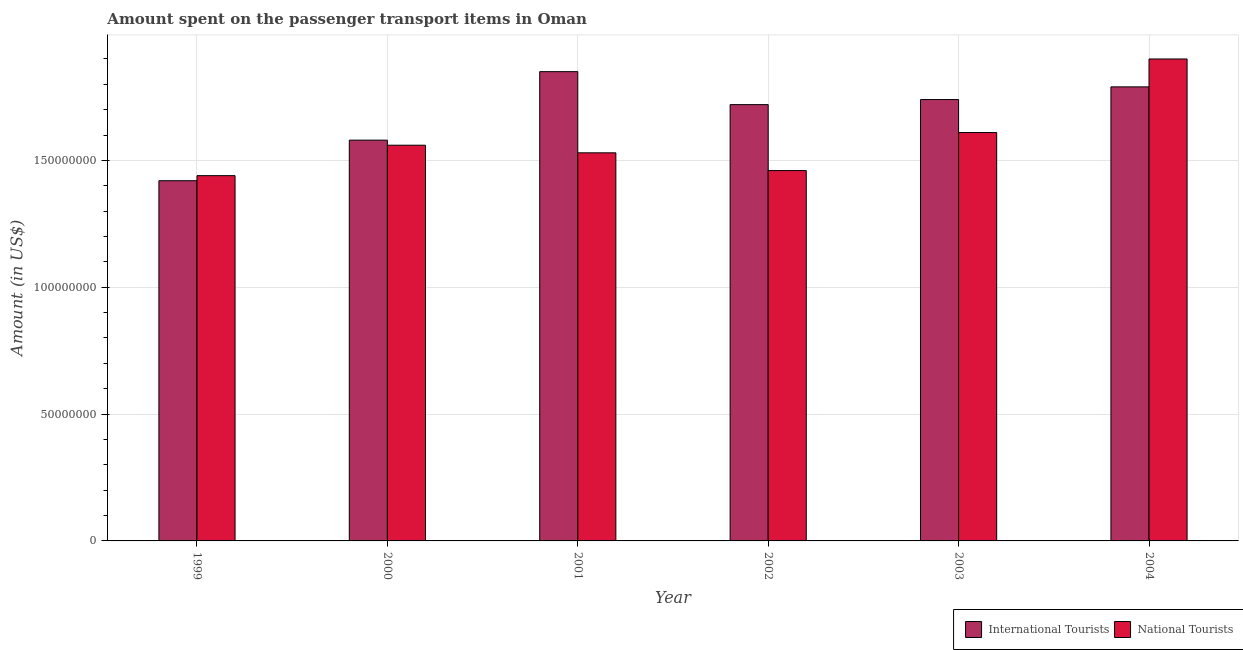How many groups of bars are there?
Provide a succinct answer. 6. How many bars are there on the 4th tick from the left?
Give a very brief answer. 2. What is the label of the 4th group of bars from the left?
Ensure brevity in your answer.  2002. In how many cases, is the number of bars for a given year not equal to the number of legend labels?
Offer a terse response. 0. What is the amount spent on transport items of international tourists in 2001?
Your answer should be compact. 1.85e+08. Across all years, what is the maximum amount spent on transport items of national tourists?
Offer a very short reply. 1.90e+08. Across all years, what is the minimum amount spent on transport items of national tourists?
Provide a succinct answer. 1.44e+08. What is the total amount spent on transport items of national tourists in the graph?
Keep it short and to the point. 9.50e+08. What is the difference between the amount spent on transport items of national tourists in 2001 and that in 2004?
Offer a terse response. -3.70e+07. What is the difference between the amount spent on transport items of national tourists in 2000 and the amount spent on transport items of international tourists in 2001?
Make the answer very short. 3.00e+06. What is the average amount spent on transport items of national tourists per year?
Your answer should be compact. 1.58e+08. In how many years, is the amount spent on transport items of international tourists greater than 70000000 US$?
Give a very brief answer. 6. What is the ratio of the amount spent on transport items of international tourists in 2000 to that in 2003?
Provide a succinct answer. 0.91. What is the difference between the highest and the second highest amount spent on transport items of national tourists?
Offer a very short reply. 2.90e+07. What is the difference between the highest and the lowest amount spent on transport items of international tourists?
Offer a terse response. 4.30e+07. What does the 1st bar from the left in 2000 represents?
Your answer should be compact. International Tourists. What does the 2nd bar from the right in 2004 represents?
Ensure brevity in your answer.  International Tourists. How many bars are there?
Offer a terse response. 12. How many years are there in the graph?
Provide a short and direct response. 6. What is the difference between two consecutive major ticks on the Y-axis?
Provide a succinct answer. 5.00e+07. How many legend labels are there?
Give a very brief answer. 2. How are the legend labels stacked?
Offer a very short reply. Horizontal. What is the title of the graph?
Provide a succinct answer. Amount spent on the passenger transport items in Oman. What is the label or title of the X-axis?
Provide a short and direct response. Year. What is the label or title of the Y-axis?
Offer a very short reply. Amount (in US$). What is the Amount (in US$) in International Tourists in 1999?
Offer a very short reply. 1.42e+08. What is the Amount (in US$) in National Tourists in 1999?
Offer a very short reply. 1.44e+08. What is the Amount (in US$) in International Tourists in 2000?
Keep it short and to the point. 1.58e+08. What is the Amount (in US$) in National Tourists in 2000?
Ensure brevity in your answer.  1.56e+08. What is the Amount (in US$) of International Tourists in 2001?
Keep it short and to the point. 1.85e+08. What is the Amount (in US$) in National Tourists in 2001?
Ensure brevity in your answer.  1.53e+08. What is the Amount (in US$) of International Tourists in 2002?
Keep it short and to the point. 1.72e+08. What is the Amount (in US$) in National Tourists in 2002?
Keep it short and to the point. 1.46e+08. What is the Amount (in US$) of International Tourists in 2003?
Provide a succinct answer. 1.74e+08. What is the Amount (in US$) in National Tourists in 2003?
Provide a succinct answer. 1.61e+08. What is the Amount (in US$) in International Tourists in 2004?
Offer a terse response. 1.79e+08. What is the Amount (in US$) in National Tourists in 2004?
Provide a succinct answer. 1.90e+08. Across all years, what is the maximum Amount (in US$) of International Tourists?
Your answer should be very brief. 1.85e+08. Across all years, what is the maximum Amount (in US$) of National Tourists?
Keep it short and to the point. 1.90e+08. Across all years, what is the minimum Amount (in US$) in International Tourists?
Provide a short and direct response. 1.42e+08. Across all years, what is the minimum Amount (in US$) in National Tourists?
Ensure brevity in your answer.  1.44e+08. What is the total Amount (in US$) in International Tourists in the graph?
Keep it short and to the point. 1.01e+09. What is the total Amount (in US$) in National Tourists in the graph?
Your answer should be very brief. 9.50e+08. What is the difference between the Amount (in US$) in International Tourists in 1999 and that in 2000?
Ensure brevity in your answer.  -1.60e+07. What is the difference between the Amount (in US$) in National Tourists in 1999 and that in 2000?
Provide a short and direct response. -1.20e+07. What is the difference between the Amount (in US$) in International Tourists in 1999 and that in 2001?
Your answer should be very brief. -4.30e+07. What is the difference between the Amount (in US$) in National Tourists in 1999 and that in 2001?
Ensure brevity in your answer.  -9.00e+06. What is the difference between the Amount (in US$) of International Tourists in 1999 and that in 2002?
Your answer should be very brief. -3.00e+07. What is the difference between the Amount (in US$) of National Tourists in 1999 and that in 2002?
Your answer should be compact. -2.00e+06. What is the difference between the Amount (in US$) in International Tourists in 1999 and that in 2003?
Keep it short and to the point. -3.20e+07. What is the difference between the Amount (in US$) of National Tourists in 1999 and that in 2003?
Provide a succinct answer. -1.70e+07. What is the difference between the Amount (in US$) in International Tourists in 1999 and that in 2004?
Your answer should be very brief. -3.70e+07. What is the difference between the Amount (in US$) in National Tourists in 1999 and that in 2004?
Offer a terse response. -4.60e+07. What is the difference between the Amount (in US$) of International Tourists in 2000 and that in 2001?
Provide a short and direct response. -2.70e+07. What is the difference between the Amount (in US$) in National Tourists in 2000 and that in 2001?
Offer a terse response. 3.00e+06. What is the difference between the Amount (in US$) of International Tourists in 2000 and that in 2002?
Provide a succinct answer. -1.40e+07. What is the difference between the Amount (in US$) in National Tourists in 2000 and that in 2002?
Give a very brief answer. 1.00e+07. What is the difference between the Amount (in US$) of International Tourists in 2000 and that in 2003?
Provide a succinct answer. -1.60e+07. What is the difference between the Amount (in US$) of National Tourists in 2000 and that in 2003?
Make the answer very short. -5.00e+06. What is the difference between the Amount (in US$) of International Tourists in 2000 and that in 2004?
Your answer should be compact. -2.10e+07. What is the difference between the Amount (in US$) in National Tourists in 2000 and that in 2004?
Provide a succinct answer. -3.40e+07. What is the difference between the Amount (in US$) of International Tourists in 2001 and that in 2002?
Provide a succinct answer. 1.30e+07. What is the difference between the Amount (in US$) of National Tourists in 2001 and that in 2002?
Offer a very short reply. 7.00e+06. What is the difference between the Amount (in US$) of International Tourists in 2001 and that in 2003?
Provide a succinct answer. 1.10e+07. What is the difference between the Amount (in US$) in National Tourists in 2001 and that in 2003?
Offer a terse response. -8.00e+06. What is the difference between the Amount (in US$) in National Tourists in 2001 and that in 2004?
Offer a very short reply. -3.70e+07. What is the difference between the Amount (in US$) of National Tourists in 2002 and that in 2003?
Keep it short and to the point. -1.50e+07. What is the difference between the Amount (in US$) of International Tourists in 2002 and that in 2004?
Your answer should be compact. -7.00e+06. What is the difference between the Amount (in US$) of National Tourists in 2002 and that in 2004?
Ensure brevity in your answer.  -4.40e+07. What is the difference between the Amount (in US$) of International Tourists in 2003 and that in 2004?
Ensure brevity in your answer.  -5.00e+06. What is the difference between the Amount (in US$) in National Tourists in 2003 and that in 2004?
Provide a succinct answer. -2.90e+07. What is the difference between the Amount (in US$) of International Tourists in 1999 and the Amount (in US$) of National Tourists in 2000?
Keep it short and to the point. -1.40e+07. What is the difference between the Amount (in US$) of International Tourists in 1999 and the Amount (in US$) of National Tourists in 2001?
Offer a terse response. -1.10e+07. What is the difference between the Amount (in US$) of International Tourists in 1999 and the Amount (in US$) of National Tourists in 2002?
Make the answer very short. -4.00e+06. What is the difference between the Amount (in US$) of International Tourists in 1999 and the Amount (in US$) of National Tourists in 2003?
Provide a succinct answer. -1.90e+07. What is the difference between the Amount (in US$) in International Tourists in 1999 and the Amount (in US$) in National Tourists in 2004?
Provide a short and direct response. -4.80e+07. What is the difference between the Amount (in US$) in International Tourists in 2000 and the Amount (in US$) in National Tourists in 2003?
Make the answer very short. -3.00e+06. What is the difference between the Amount (in US$) of International Tourists in 2000 and the Amount (in US$) of National Tourists in 2004?
Ensure brevity in your answer.  -3.20e+07. What is the difference between the Amount (in US$) of International Tourists in 2001 and the Amount (in US$) of National Tourists in 2002?
Your answer should be very brief. 3.90e+07. What is the difference between the Amount (in US$) in International Tourists in 2001 and the Amount (in US$) in National Tourists in 2003?
Offer a terse response. 2.40e+07. What is the difference between the Amount (in US$) of International Tourists in 2001 and the Amount (in US$) of National Tourists in 2004?
Provide a short and direct response. -5.00e+06. What is the difference between the Amount (in US$) in International Tourists in 2002 and the Amount (in US$) in National Tourists in 2003?
Your response must be concise. 1.10e+07. What is the difference between the Amount (in US$) in International Tourists in 2002 and the Amount (in US$) in National Tourists in 2004?
Your answer should be compact. -1.80e+07. What is the difference between the Amount (in US$) of International Tourists in 2003 and the Amount (in US$) of National Tourists in 2004?
Keep it short and to the point. -1.60e+07. What is the average Amount (in US$) in International Tourists per year?
Make the answer very short. 1.68e+08. What is the average Amount (in US$) in National Tourists per year?
Provide a short and direct response. 1.58e+08. In the year 2001, what is the difference between the Amount (in US$) of International Tourists and Amount (in US$) of National Tourists?
Ensure brevity in your answer.  3.20e+07. In the year 2002, what is the difference between the Amount (in US$) in International Tourists and Amount (in US$) in National Tourists?
Offer a terse response. 2.60e+07. In the year 2003, what is the difference between the Amount (in US$) of International Tourists and Amount (in US$) of National Tourists?
Provide a short and direct response. 1.30e+07. In the year 2004, what is the difference between the Amount (in US$) in International Tourists and Amount (in US$) in National Tourists?
Offer a very short reply. -1.10e+07. What is the ratio of the Amount (in US$) in International Tourists in 1999 to that in 2000?
Provide a short and direct response. 0.9. What is the ratio of the Amount (in US$) of International Tourists in 1999 to that in 2001?
Ensure brevity in your answer.  0.77. What is the ratio of the Amount (in US$) of National Tourists in 1999 to that in 2001?
Your answer should be very brief. 0.94. What is the ratio of the Amount (in US$) of International Tourists in 1999 to that in 2002?
Your answer should be very brief. 0.83. What is the ratio of the Amount (in US$) of National Tourists in 1999 to that in 2002?
Give a very brief answer. 0.99. What is the ratio of the Amount (in US$) in International Tourists in 1999 to that in 2003?
Give a very brief answer. 0.82. What is the ratio of the Amount (in US$) of National Tourists in 1999 to that in 2003?
Your answer should be very brief. 0.89. What is the ratio of the Amount (in US$) of International Tourists in 1999 to that in 2004?
Ensure brevity in your answer.  0.79. What is the ratio of the Amount (in US$) of National Tourists in 1999 to that in 2004?
Offer a terse response. 0.76. What is the ratio of the Amount (in US$) in International Tourists in 2000 to that in 2001?
Provide a short and direct response. 0.85. What is the ratio of the Amount (in US$) in National Tourists in 2000 to that in 2001?
Your answer should be compact. 1.02. What is the ratio of the Amount (in US$) in International Tourists in 2000 to that in 2002?
Offer a terse response. 0.92. What is the ratio of the Amount (in US$) of National Tourists in 2000 to that in 2002?
Make the answer very short. 1.07. What is the ratio of the Amount (in US$) in International Tourists in 2000 to that in 2003?
Keep it short and to the point. 0.91. What is the ratio of the Amount (in US$) of National Tourists in 2000 to that in 2003?
Your answer should be very brief. 0.97. What is the ratio of the Amount (in US$) in International Tourists in 2000 to that in 2004?
Provide a short and direct response. 0.88. What is the ratio of the Amount (in US$) of National Tourists in 2000 to that in 2004?
Provide a short and direct response. 0.82. What is the ratio of the Amount (in US$) in International Tourists in 2001 to that in 2002?
Your response must be concise. 1.08. What is the ratio of the Amount (in US$) in National Tourists in 2001 to that in 2002?
Offer a terse response. 1.05. What is the ratio of the Amount (in US$) of International Tourists in 2001 to that in 2003?
Provide a succinct answer. 1.06. What is the ratio of the Amount (in US$) of National Tourists in 2001 to that in 2003?
Offer a terse response. 0.95. What is the ratio of the Amount (in US$) of International Tourists in 2001 to that in 2004?
Ensure brevity in your answer.  1.03. What is the ratio of the Amount (in US$) of National Tourists in 2001 to that in 2004?
Ensure brevity in your answer.  0.81. What is the ratio of the Amount (in US$) in International Tourists in 2002 to that in 2003?
Keep it short and to the point. 0.99. What is the ratio of the Amount (in US$) in National Tourists in 2002 to that in 2003?
Your response must be concise. 0.91. What is the ratio of the Amount (in US$) of International Tourists in 2002 to that in 2004?
Your answer should be compact. 0.96. What is the ratio of the Amount (in US$) of National Tourists in 2002 to that in 2004?
Your answer should be very brief. 0.77. What is the ratio of the Amount (in US$) of International Tourists in 2003 to that in 2004?
Your response must be concise. 0.97. What is the ratio of the Amount (in US$) of National Tourists in 2003 to that in 2004?
Your response must be concise. 0.85. What is the difference between the highest and the second highest Amount (in US$) of International Tourists?
Ensure brevity in your answer.  6.00e+06. What is the difference between the highest and the second highest Amount (in US$) in National Tourists?
Provide a short and direct response. 2.90e+07. What is the difference between the highest and the lowest Amount (in US$) in International Tourists?
Your response must be concise. 4.30e+07. What is the difference between the highest and the lowest Amount (in US$) of National Tourists?
Provide a succinct answer. 4.60e+07. 